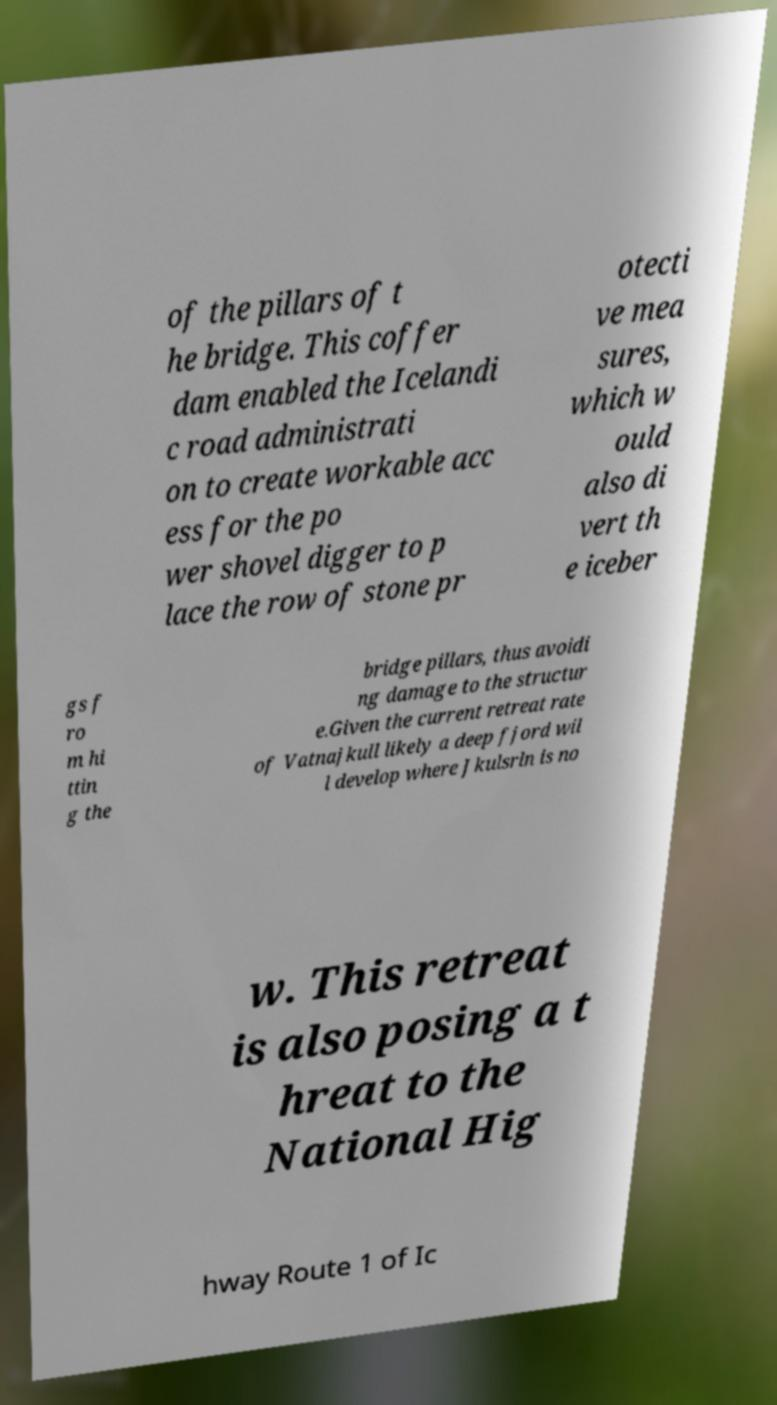What messages or text are displayed in this image? I need them in a readable, typed format. of the pillars of t he bridge. This coffer dam enabled the Icelandi c road administrati on to create workable acc ess for the po wer shovel digger to p lace the row of stone pr otecti ve mea sures, which w ould also di vert th e iceber gs f ro m hi ttin g the bridge pillars, thus avoidi ng damage to the structur e.Given the current retreat rate of Vatnajkull likely a deep fjord wil l develop where Jkulsrln is no w. This retreat is also posing a t hreat to the National Hig hway Route 1 of Ic 